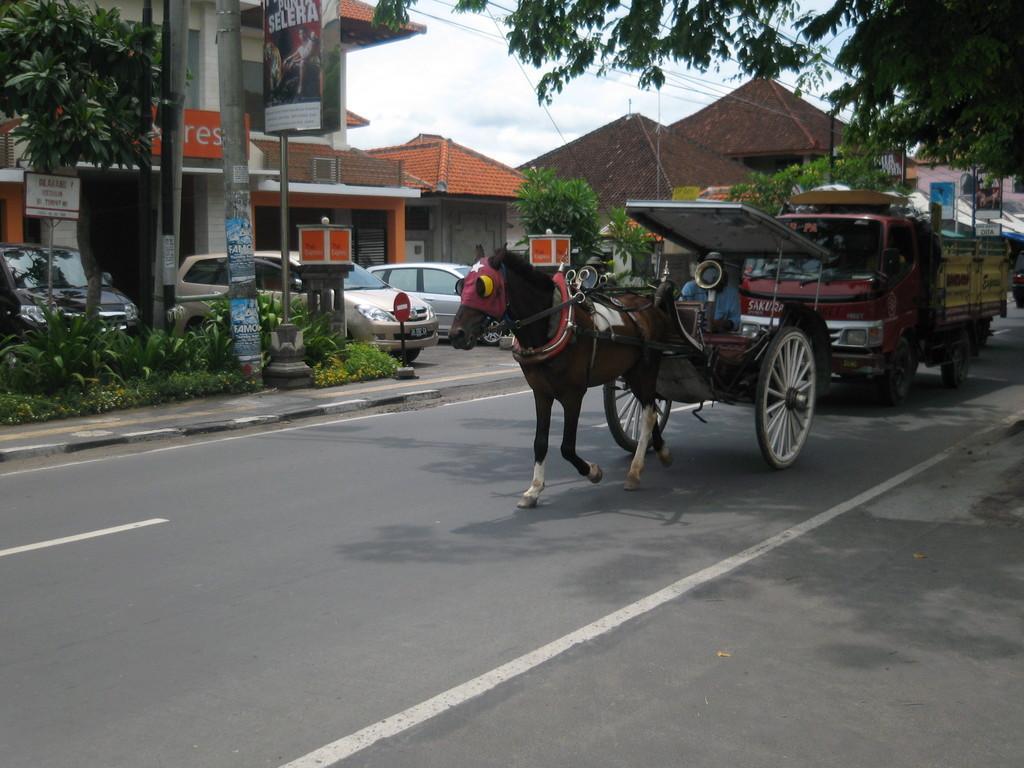Can you describe this image briefly? In this picture there is a man who is riding a chariot on the road. At the back there is a truck. On the left we can see three cars which is parked near to the sign board, poles, trees, plants, grass and buildings. On the right background we can see the hut, house, street lights, electric pole and wires. At the top we can see the sky and clouds. 